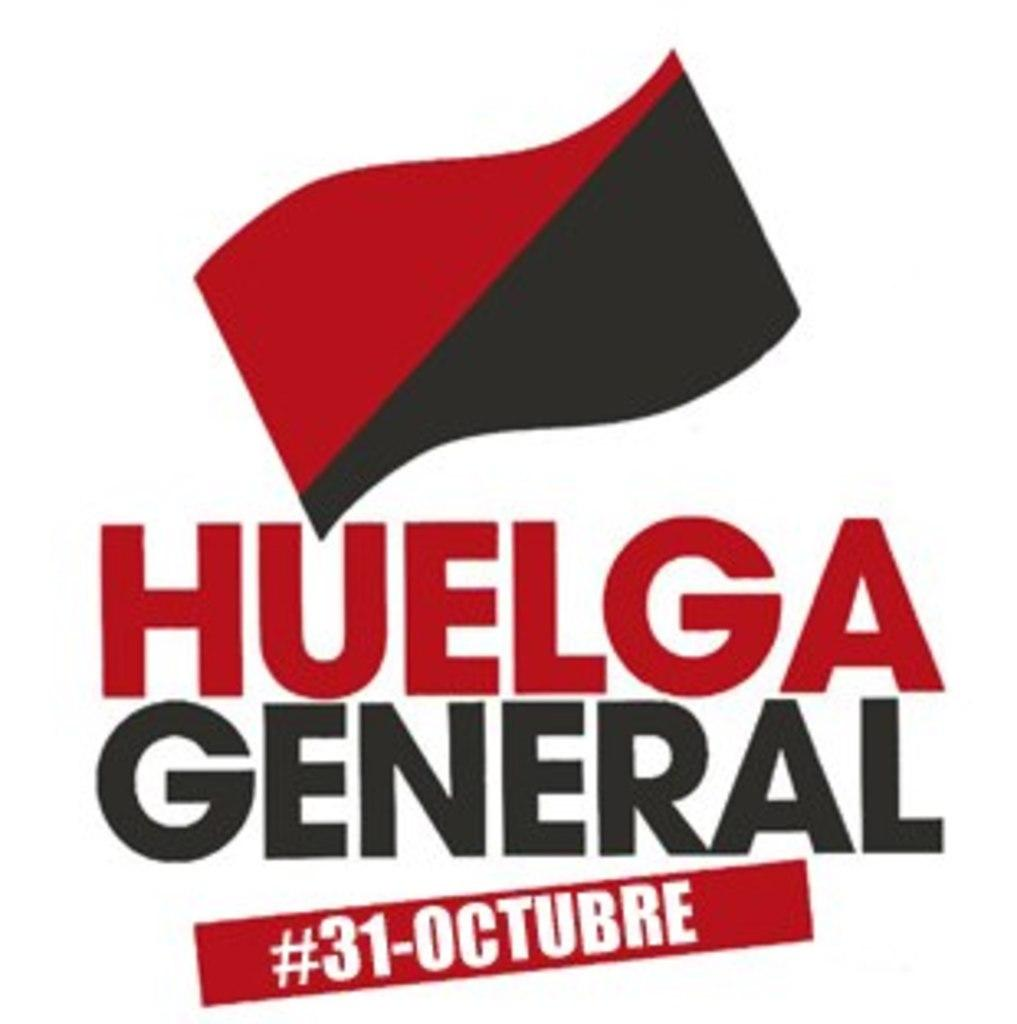<image>
Write a terse but informative summary of the picture. Use hashtag #31-Octubre for information on Huelga General. 